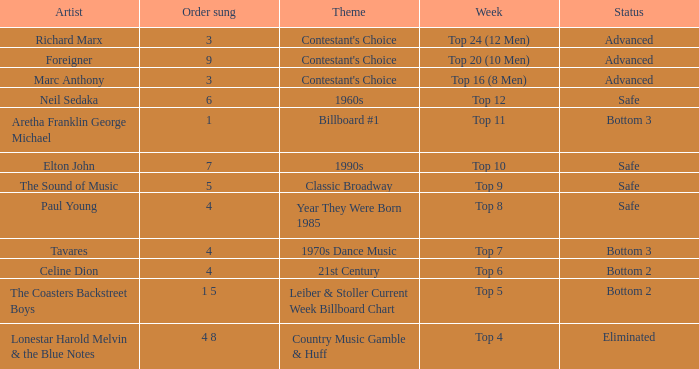What week did the contestant finish in the bottom 2 with a Celine Dion song? Top 6. 